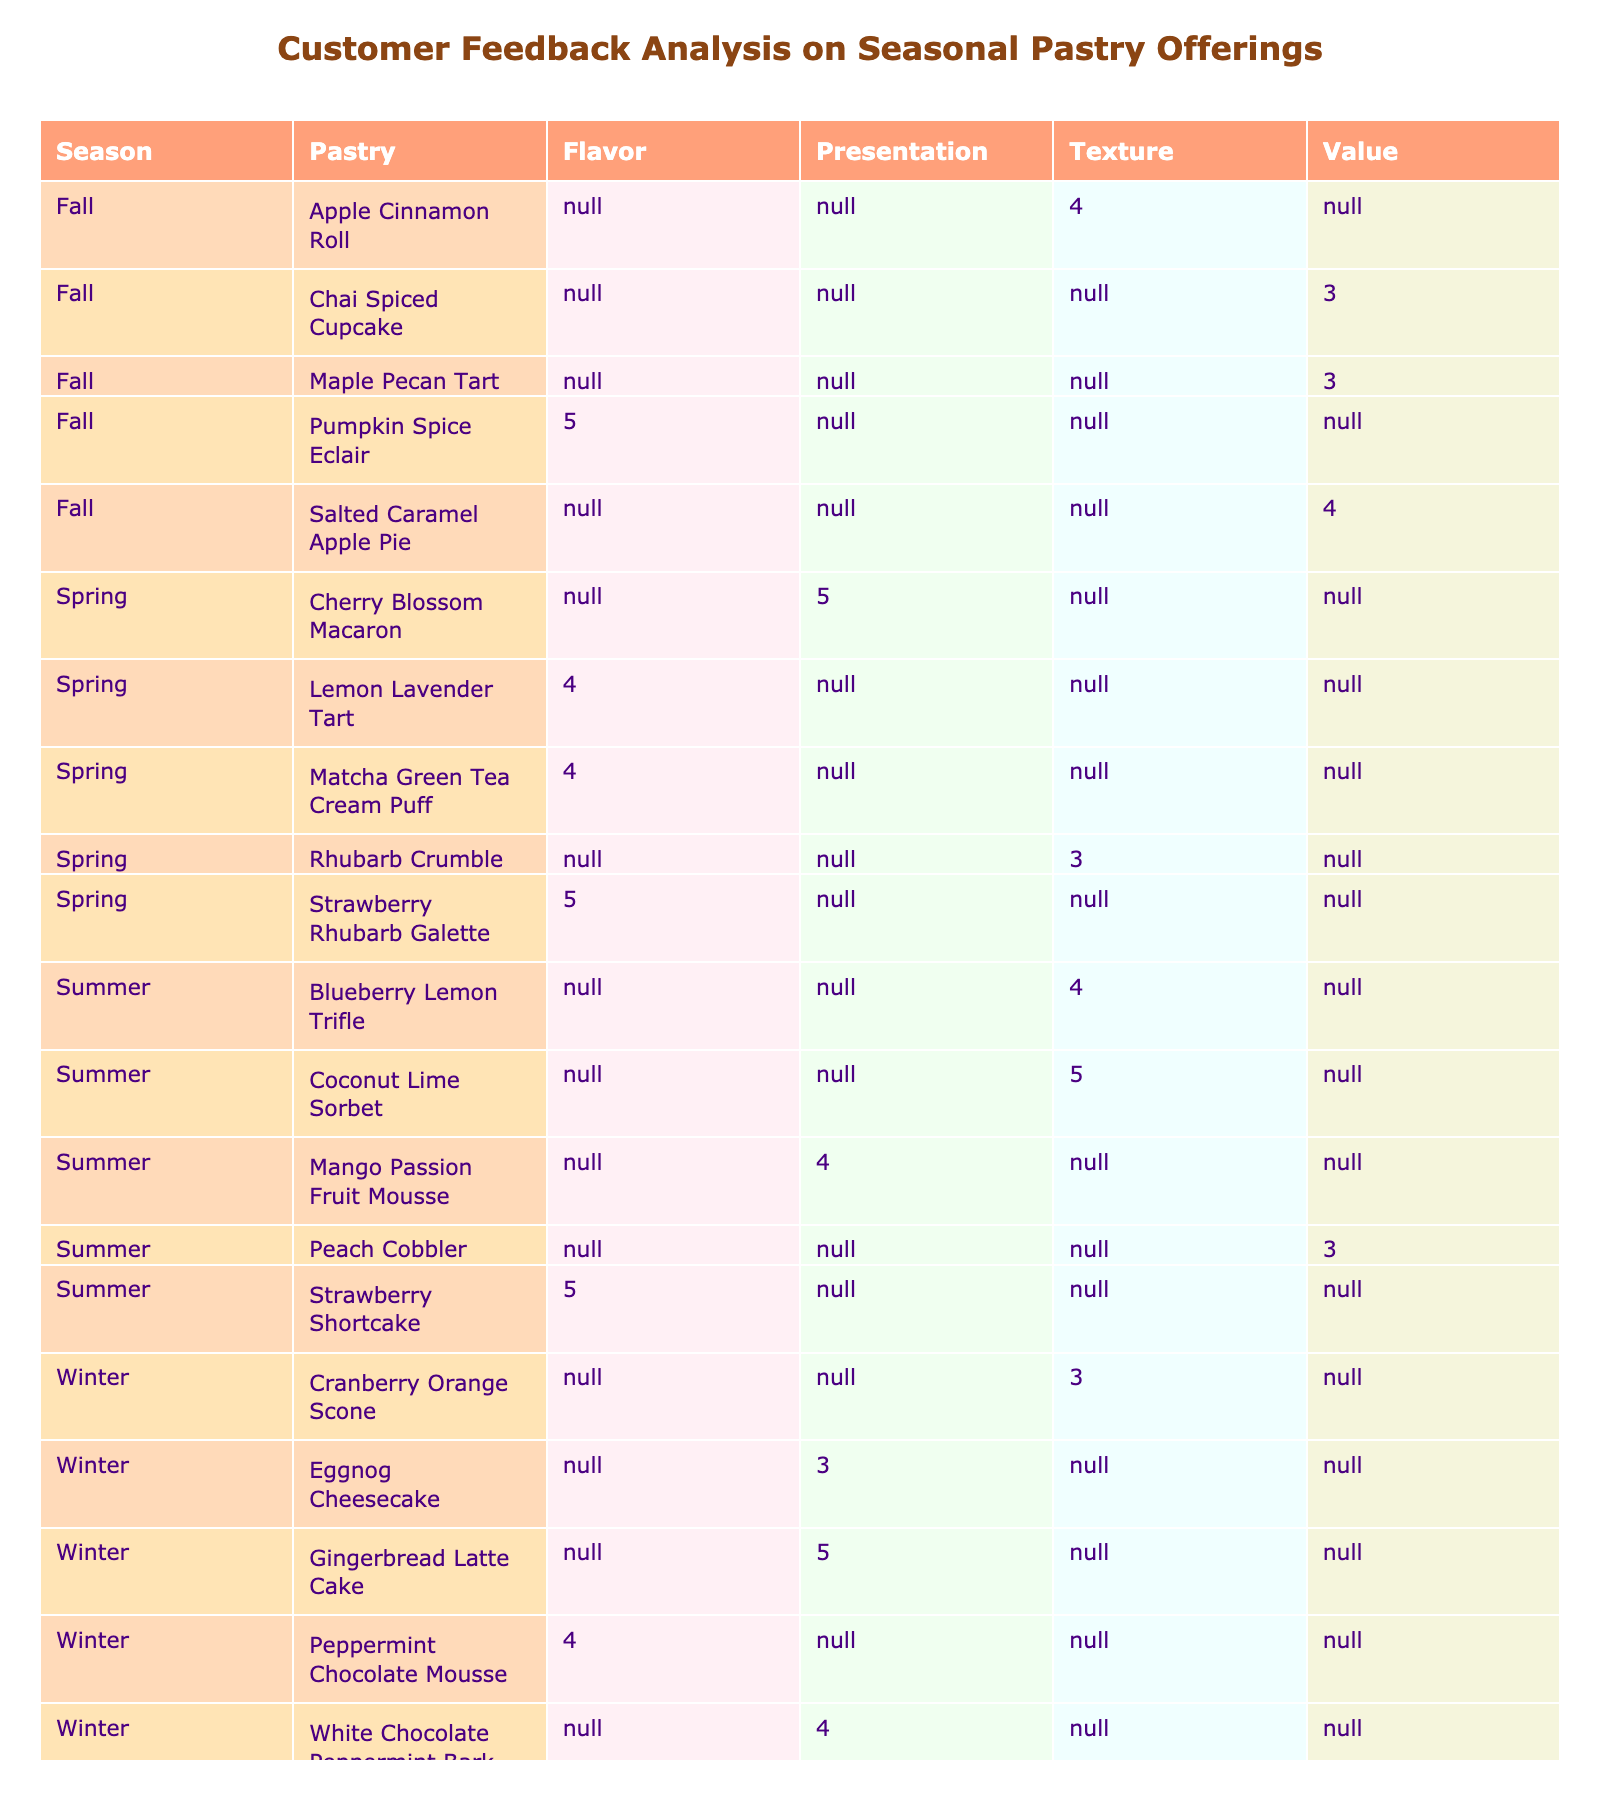What is the highest rating received for the Lemon Lavender Tart? In the table, I can locate the Lemon Lavender Tart under the Spring category. The only rating listed for this pastry is 4, making it the highest rating it has received.
Answer: 4 Which pastry in Summer has the highest flavor rating? By checking the Summer section, I can see that the Strawberry Shortcake has a rating of 5 for flavor, while the Mango Passion Fruit Mousse has a rating of 4 and the Peach Cobbler has a rating of 3. Therefore, the highest flavor rating in Summer pertains to the Strawberry Shortcake.
Answer: Strawberry Shortcake Was there a pastry in Fall that received a texture rating lower than 4? In the Fall section, I see three pastries: the Pumpkin Spice Eclair (5 for flavor), the Apple Cinnamon Roll (4 for texture), and the Maple Pecan Tart (3 for value). The Maple Pecan Tart has a rating of 3 for value, which is lower than 4, so the answer is yes.
Answer: Yes What is the average rating for pastries categorized under presentation? To find the average rating for the presentation category, I will collect the ratings associated with the presentations: Cherry Blossom Macaron (5), Mango Passion Fruit Mousse (4), Gingerbread Latte Cake (5), Peppermint Chocolate Mousse (4), Eggnog Cheesecake (3), and White Chocolate Peppermint Bark (4). Summing these gives 25 (5 + 4 + 5 + 4 + 3 + 4) and dividing by the number of pastries (6) results in an average of 4.17.
Answer: 4.17 Which season had the most pastries rated with a value feedback category? From the table, I can see that Fall has three pastries presented, namely the Maple Pecan Tart (3 for value), the Salted Caramel Apple Pie (4 for value), and the Chai Spiced Cupcake (3 for value). Comparing this with other seasons, Spring and Summer each have one, and Winter has none, therefore, Fall is the season with the most pastries rated under the value category.
Answer: Fall 